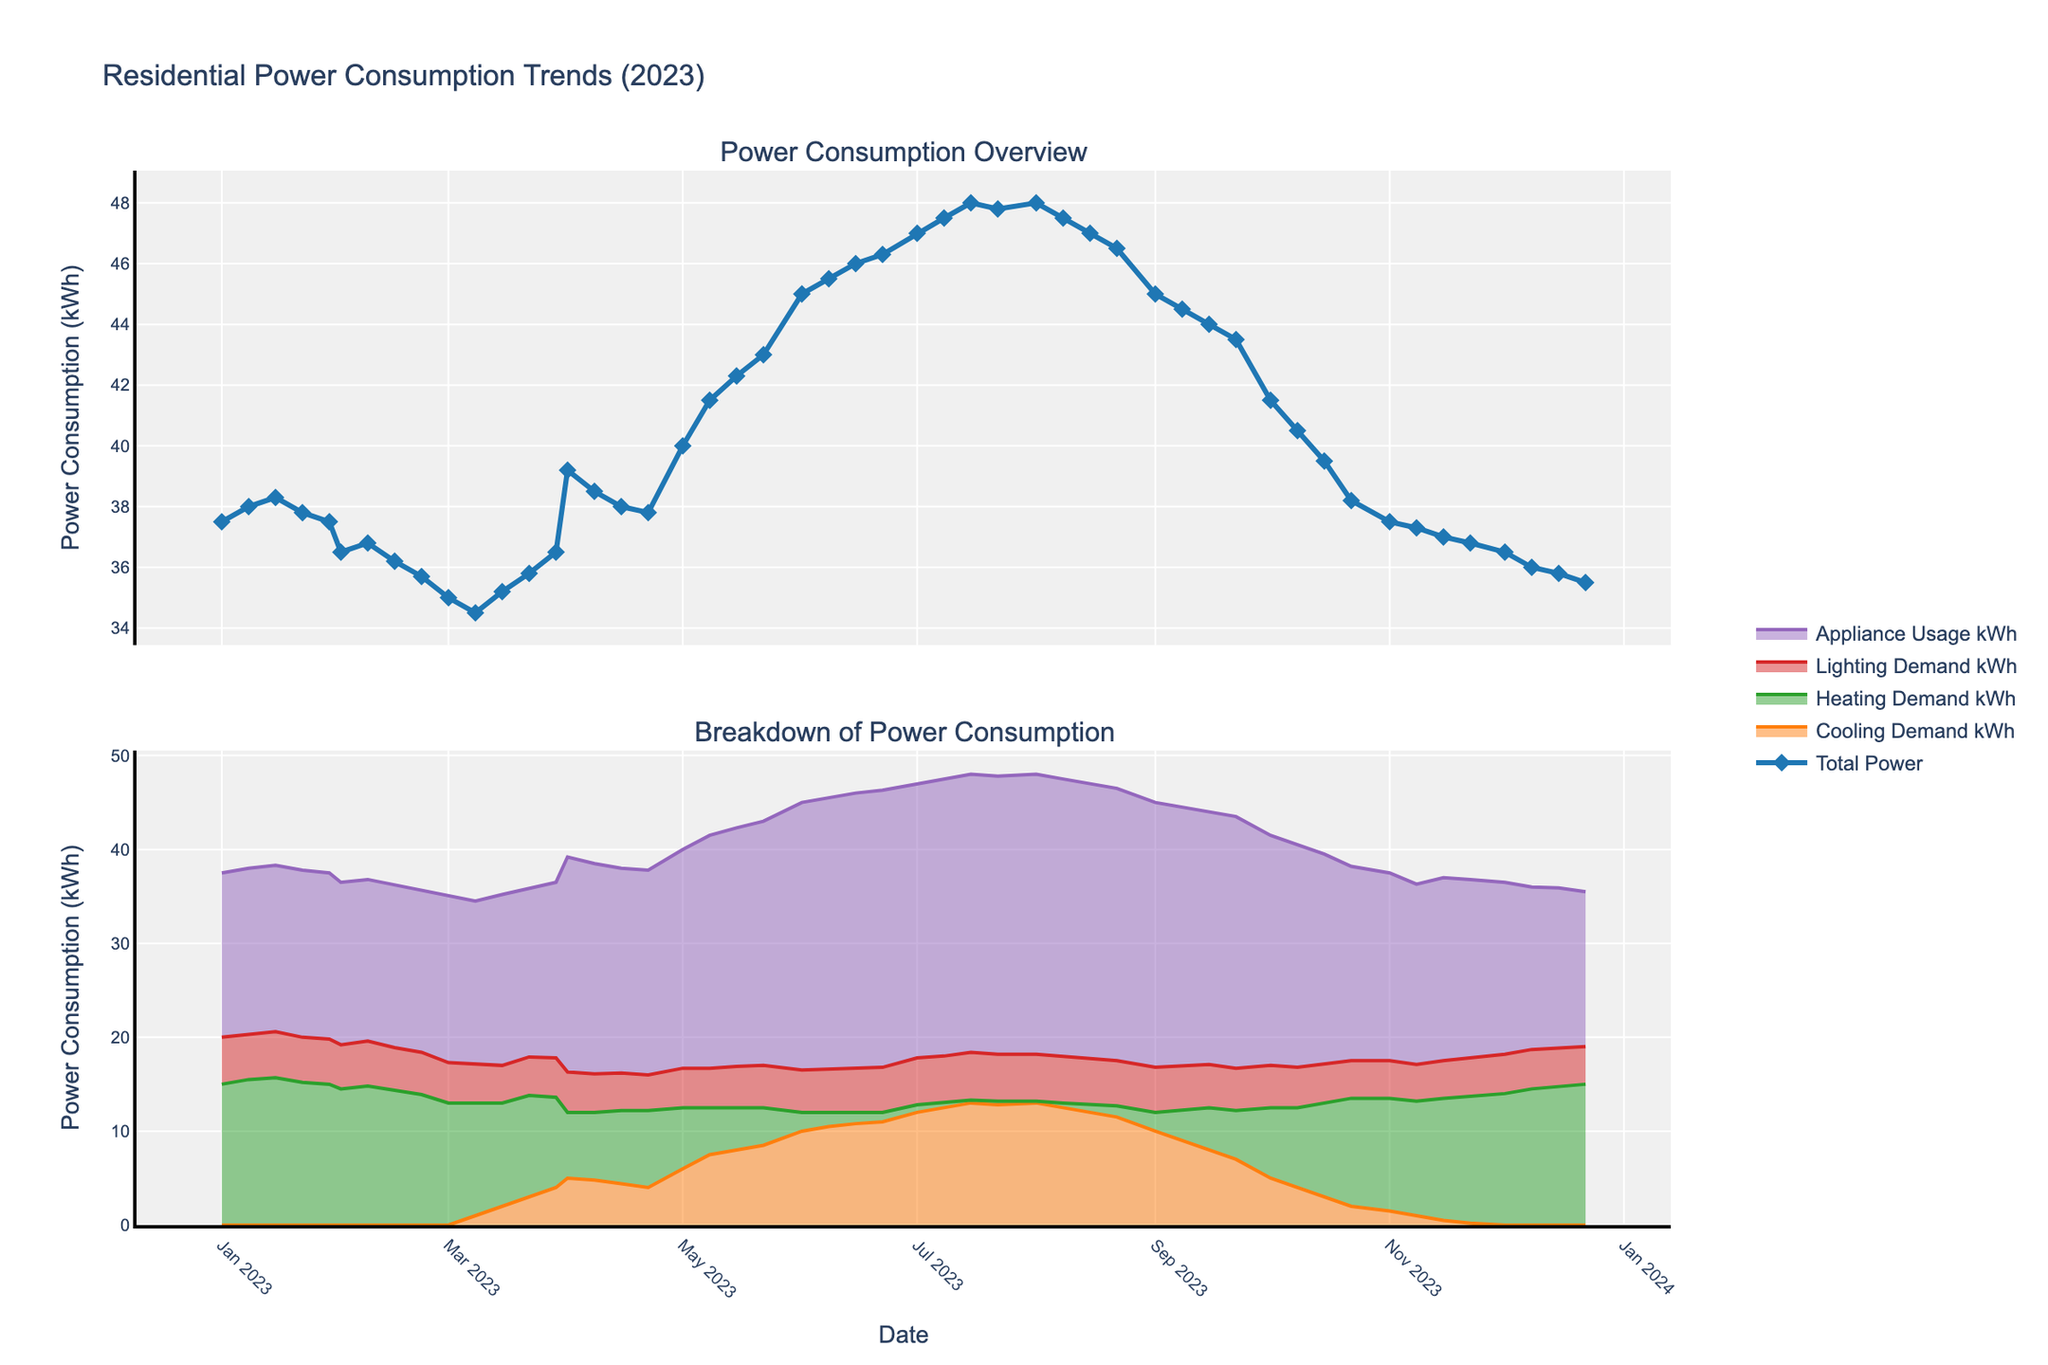What is the title of the plot? The title of the plot is usually found at the top of the figure, clearly stating the subject of the visualization. In this plot, it is specified as 'Residential Power Consumption Trends (2023)'.
Answer: Residential Power Consumption Trends (2023) What are the main components of power consumption displayed in the second subplot? The components are typically listed in the legend associated with the subplot. In this plot, they are 'Cooling Demand', 'Heating Demand', 'Lighting Demand', and 'Appliance Usage'.
Answer: Cooling Demand, Heating Demand, Lighting Demand, Appliance Usage How does the total power consumption trend from January to December? Look at the trend line for 'Total Power' in the first subplot. The trend starts around 37.5 kWh in January, peaks at around 48.0 kWh in July, and then decreases back to around 35.5 kWh by December.
Answer: It increases from January to July and then decreases until December Which month shows the maximum 'Cooling Demand'? Identify the peak point in the 'Cooling Demand' line in the second subplot. The highest point is around July, where the value is approximately 13.0 kWh.
Answer: July What happens to 'Heating Demand' and 'Cooling Demand' between January and July? Observe both lines in the second subplot. 'Heating Demand' decreases from about 15.0 kWh in January to nearly 0.3 kWh in July, while 'Cooling Demand' increases from 0 kWh to 13.0 kWh.
Answer: Heating Demand decreases, and Cooling Demand increases What is the total power consumption in the first week of June? Locate the data point for June 1 and read the 'Total Power' value from the first subplot. The power consumption is recorded as 45.0 kWh.
Answer: 45.0 kWh Compare the 'Lighting Demand' in January with that in July. Check the 'Lighting Demand' values in the second subplot for the two months. In January, it is around 4.8 kWh, while in July, it is approximately 5.0 kWh.
Answer: It's slightly higher in July compared to January What is the average 'Appliance Usage' over the year? Sum up the 'Appliance Usage' values for each month and divide by the number of months. The sum is roughly 800.0 kWh, and there are 12 months, so the average is 800.0/12.
Answer: 66.67 kWh In which month does 'Total Power' reach its peak, and what is the value? Identify the highest point in the 'Total Power' line in the first subplot. This peak occurs in July, where the value is approximately 48.0 kWh.
Answer: July, 48.0 kWh Is there any month where 'Cooling Demand' and 'Heating Demand' are equal? Look for any intersection points between the 'Cooling Demand' and 'Heating Demand' lines in the second subplot. There is no month where both demands intersect exactly at the same value.
Answer: No 